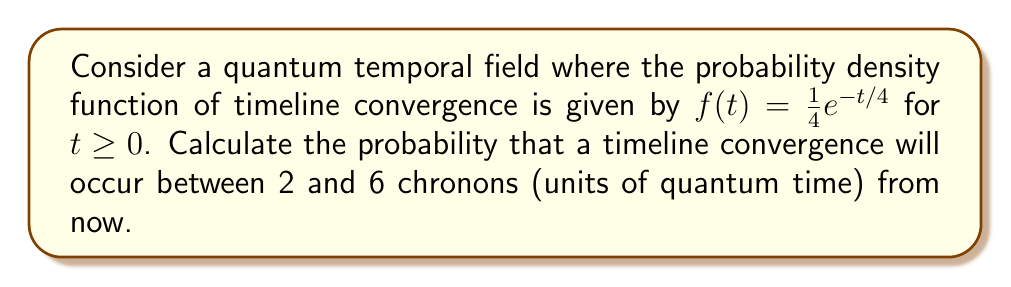Provide a solution to this math problem. To solve this problem, we need to integrate the probability density function over the given interval. The integral calculus approach is as follows:

1) The probability of an event occurring within an interval $[a, b]$ is given by the integral of the probability density function over that interval:

   $P(a \leq T \leq b) = \int_a^b f(t) dt$

2) In this case, we need to calculate:

   $P(2 \leq T \leq 6) = \int_2^6 \frac{1}{4}e^{-t/4} dt$

3) To solve this integral, we can use the substitution method:
   Let $u = -t/4$, then $du = -\frac{1}{4}dt$ or $dt = -4du$

4) Changing the limits of integration:
   When $t = 2$, $u = -1/2$
   When $t = 6$, $u = -3/2$

5) Rewriting the integral:

   $\int_2^6 \frac{1}{4}e^{-t/4} dt = \int_{-1/2}^{-3/2} e^u (-4du) = -4 \int_{-1/2}^{-3/2} e^u du$

6) The integral of $e^u$ is $e^u + C$, so:

   $-4 \int_{-1/2}^{-3/2} e^u du = -4 [e^u]_{-1/2}^{-3/2} = -4(e^{-3/2} - e^{-1/2})$

7) Simplifying:

   $-4(e^{-3/2} - e^{-1/2}) = -4e^{-3/2} + 4e^{-1/2} = 4(e^{-1/2} - e^{-3/2})$

8) This can be further simplified to:

   $4(e^{-1/2} - e^{-3/2}) = 4e^{-1/2}(1 - e^{-1})$
Answer: The probability of timeline convergence between 2 and 6 chronons from now is $4e^{-1/2}(1 - e^{-1}) \approx 0.2325$ or about 23.25%. 